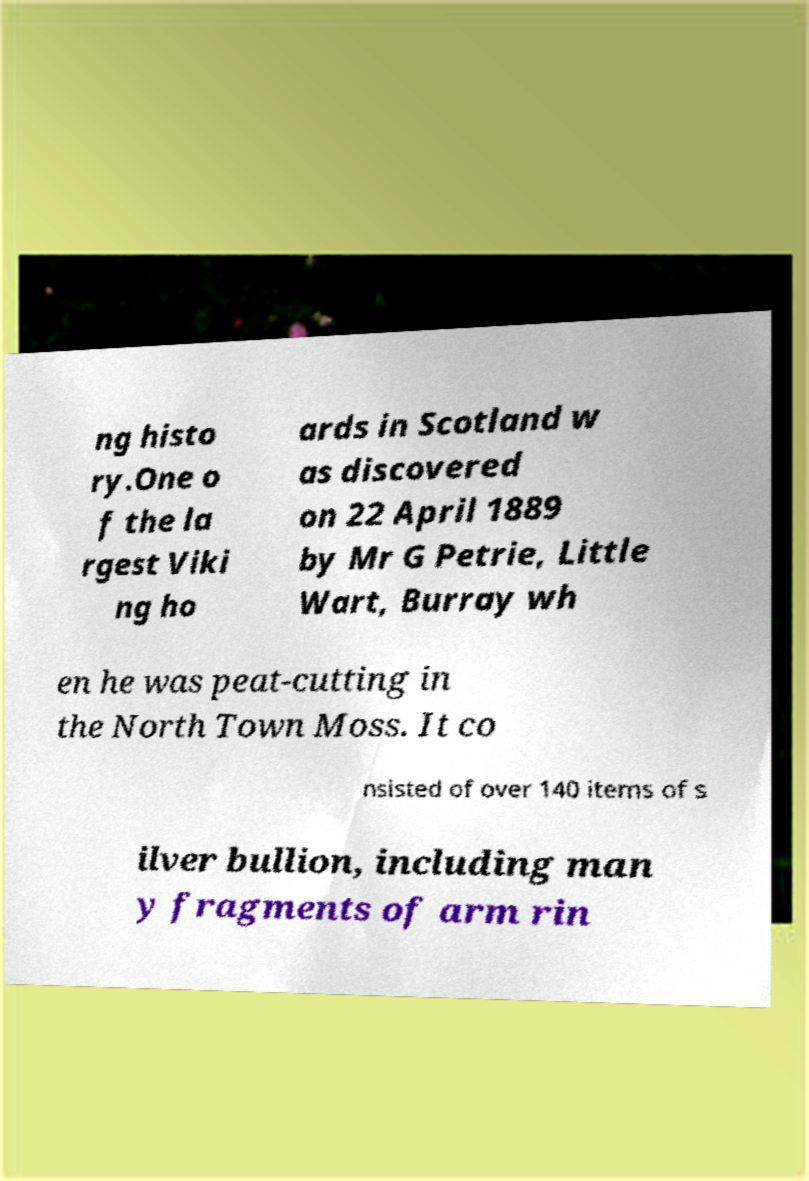I need the written content from this picture converted into text. Can you do that? ng histo ry.One o f the la rgest Viki ng ho ards in Scotland w as discovered on 22 April 1889 by Mr G Petrie, Little Wart, Burray wh en he was peat-cutting in the North Town Moss. It co nsisted of over 140 items of s ilver bullion, including man y fragments of arm rin 